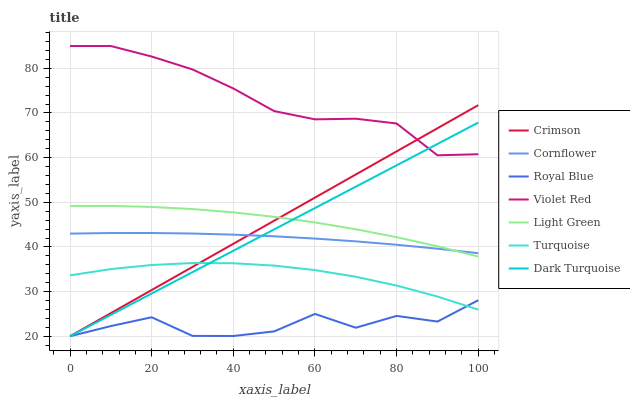Does Royal Blue have the minimum area under the curve?
Answer yes or no. Yes. Does Violet Red have the maximum area under the curve?
Answer yes or no. Yes. Does Dark Turquoise have the minimum area under the curve?
Answer yes or no. No. Does Dark Turquoise have the maximum area under the curve?
Answer yes or no. No. Is Dark Turquoise the smoothest?
Answer yes or no. Yes. Is Royal Blue the roughest?
Answer yes or no. Yes. Is Violet Red the smoothest?
Answer yes or no. No. Is Violet Red the roughest?
Answer yes or no. No. Does Dark Turquoise have the lowest value?
Answer yes or no. Yes. Does Violet Red have the lowest value?
Answer yes or no. No. Does Violet Red have the highest value?
Answer yes or no. Yes. Does Dark Turquoise have the highest value?
Answer yes or no. No. Is Turquoise less than Cornflower?
Answer yes or no. Yes. Is Violet Red greater than Cornflower?
Answer yes or no. Yes. Does Dark Turquoise intersect Turquoise?
Answer yes or no. Yes. Is Dark Turquoise less than Turquoise?
Answer yes or no. No. Is Dark Turquoise greater than Turquoise?
Answer yes or no. No. Does Turquoise intersect Cornflower?
Answer yes or no. No. 